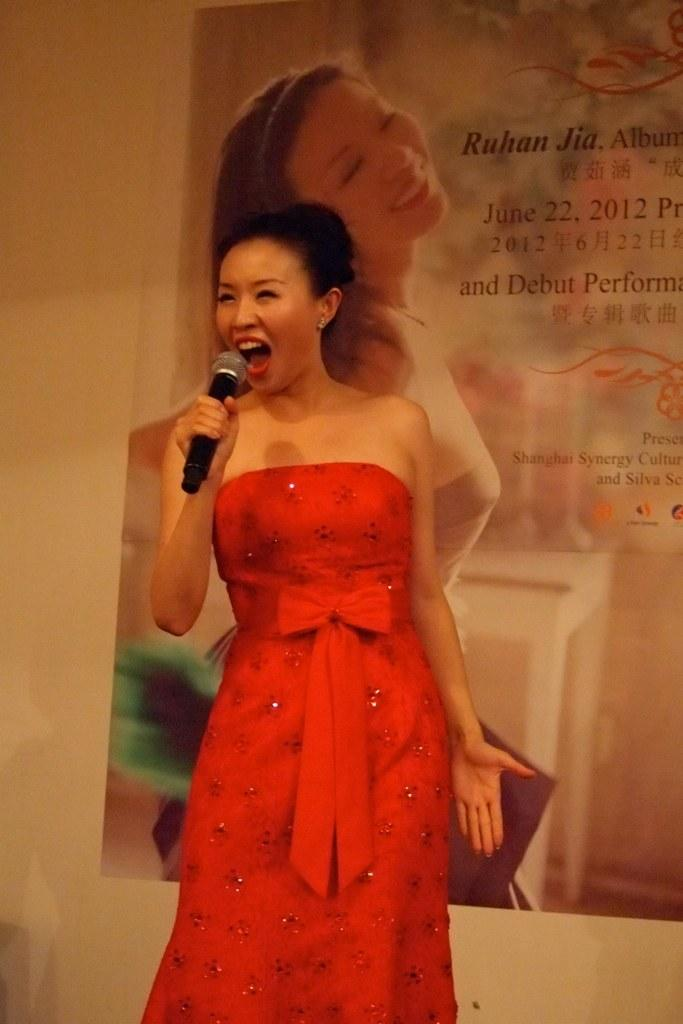What is the main subject of the image? The main subject of the image is a woman. What is the woman doing in the image? The woman is standing and singing in the image. What is the woman holding in the image? The woman is holding a microphone in the image. What can be seen in the background of the image? There is a poster visible in the background. What type of growth can be seen on the microphone in the image? There is no growth visible on the microphone in the image. What flavor of ice cream is being served at the event in the image? There is no mention of ice cream or an event in the image. 